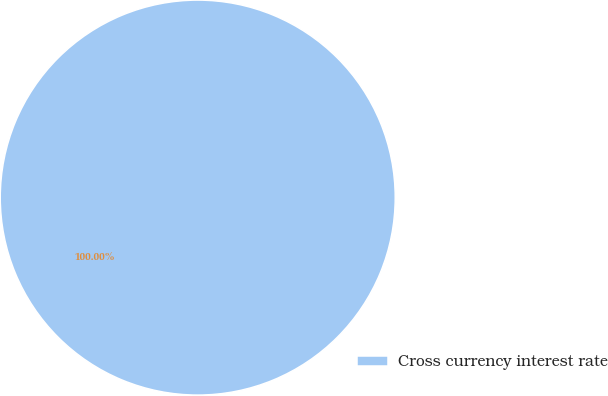Convert chart. <chart><loc_0><loc_0><loc_500><loc_500><pie_chart><fcel>Cross currency interest rate<nl><fcel>100.0%<nl></chart> 